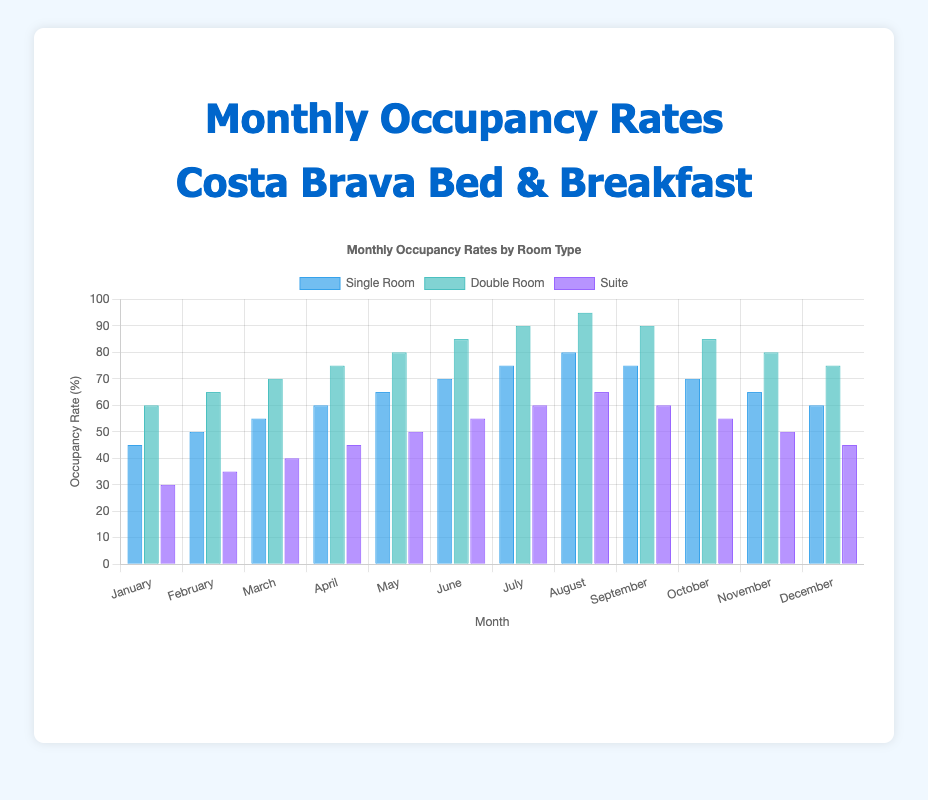What month has the highest occupancy rate for Double Rooms? Look at the highest bar for the Double Room category. It appears to be in August with a rate of 95%.
Answer: August What is the average occupancy rate for Single Rooms in the first quarter (January to March)? Add the occupancy rates for Single Rooms in January (45%), February (50%), and March (55%) and then divide by 3. (45 + 50 + 55) / 3 = 50%.
Answer: 50% Compare the occupancy rates of Suites in July and October. Which month has a higher rate? See the heights of the bars for Suites in July and October. July has a 60% occupancy rate, while October has a 55% rate.
Answer: July What is the difference in occupancy rates between Single Rooms and Suites in June? Subtract the occupancy rate of Suites from Single Rooms in June. (70% - 55%) = 15%.
Answer: 15% In which month are the occupancy rates for Single Rooms, Double Rooms, and Suites equal to each other most closely? Look for the month where the bars for Single Rooms, Double Rooms, and Suites are closest in height. In December, Single Room (60%), Double Room (75%), and Suite (45%) show relatively closer rates compared to other months.
Answer: December Which room type shows the highest increase in occupancy rate from January to August? Calculate the difference from January to August for each room type. For Single Rooms, the increase is (80% - 45%) = 35%. For Double Rooms, (95% - 60%) = 35%. For Suites, (65% - 30%) = 35%. Hence, all room types have the same increase.
Answer: All room types (35%) What is the total occupancy rate for all room types combined in April? Add the occupancy rates of Single Room, Double Room, and Suite in April. (60% + 75% + 45%) = 180%.
Answer: 180% Is there any month where the occupancy rate of Single Rooms is more than Double Rooms? Compare each month's Single Room occupancy rate with Double Room occupancy. There is no such month where Single Room occupancy exceeds Double Room occupancy.
Answer: No Which month shows the steepest decline in occupancy rate for Single Rooms from the previous month? Identify months with the largest decline in Single Room occupancy from the previous month. October to November drops from 70% to 65%, a decline of 5%.
Answer: November What is the ratio of Double Room to Suite occupancy rates in March? Divide the occupancy rate of Double Rooms by Suite occupancy in March. (70 / 40) = 1.75.
Answer: 1.75 